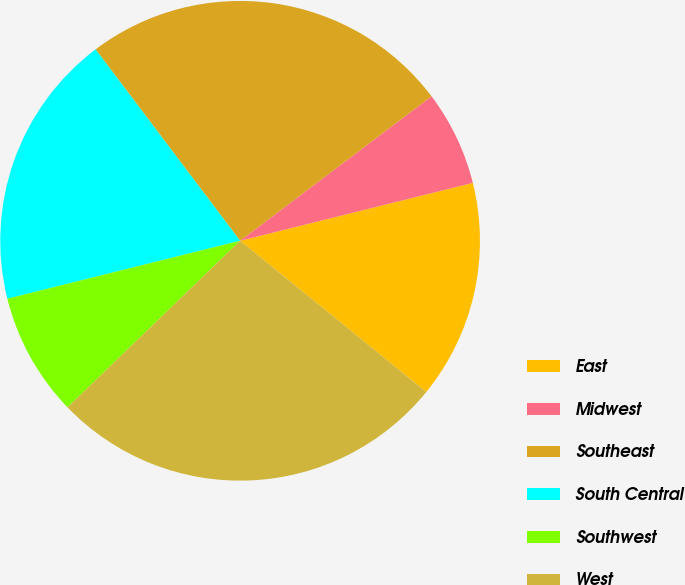Convert chart. <chart><loc_0><loc_0><loc_500><loc_500><pie_chart><fcel>East<fcel>Midwest<fcel>Southeast<fcel>South Central<fcel>Southwest<fcel>West<nl><fcel>14.74%<fcel>6.41%<fcel>25.0%<fcel>18.59%<fcel>8.33%<fcel>26.92%<nl></chart> 